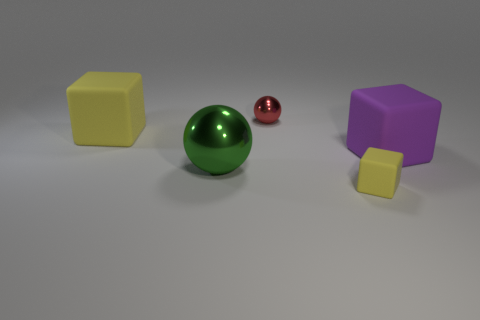What is the material of the other object that is the same shape as the small metal thing?
Your response must be concise. Metal. What is the shape of the large yellow rubber thing?
Keep it short and to the point. Cube. What material is the cube that is on the right side of the big green shiny object and behind the small yellow cube?
Your answer should be very brief. Rubber. There is another large thing that is made of the same material as the purple object; what is its shape?
Provide a short and direct response. Cube. There is a object that is made of the same material as the tiny red ball; what size is it?
Give a very brief answer. Large. There is a large thing that is to the right of the large yellow cube and left of the red thing; what shape is it?
Offer a terse response. Sphere. What is the size of the yellow cube that is behind the metal object that is in front of the big purple thing?
Offer a terse response. Large. What number of other objects are the same color as the tiny cube?
Your answer should be compact. 1. What is the big green thing made of?
Give a very brief answer. Metal. Are any large green matte spheres visible?
Offer a terse response. No. 